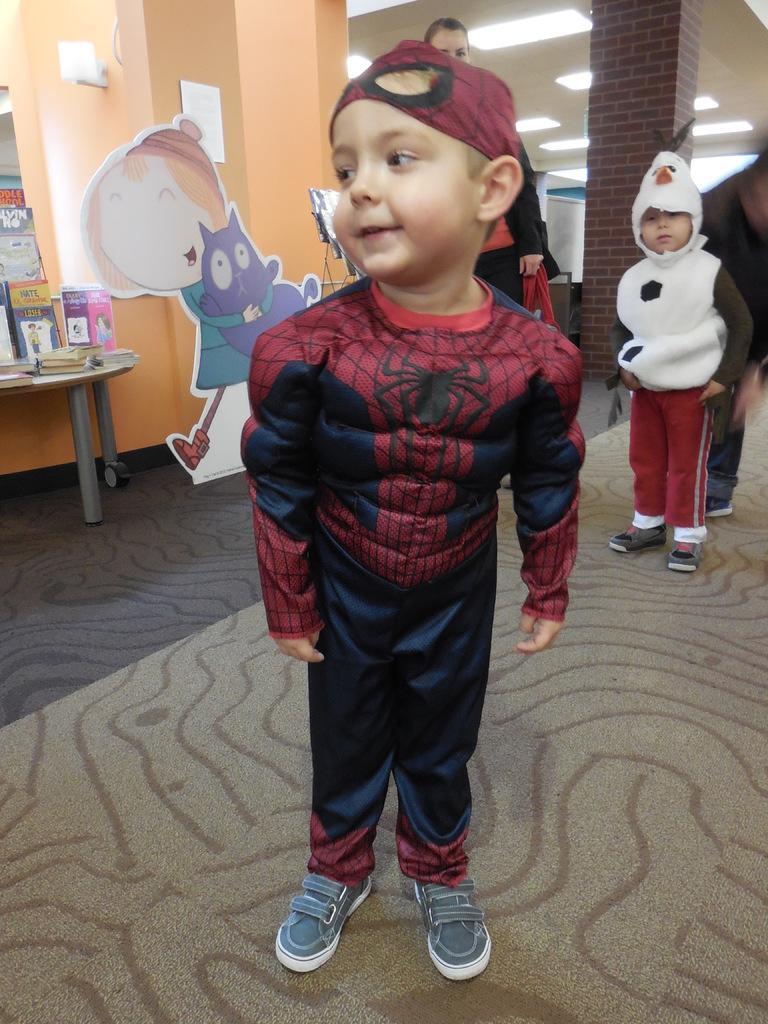Can you describe this image briefly? On the background we can see a wall and a pillar with bricks. This is a ceiling and these are lights. This is a floor and carpet. Here we can see a cartoon doll. Here on the table we can see books. We can see two boys wearing fancy dresses and standing on the floor. Here we can see one person standing. Here we can see one man bending behind to this boy. 